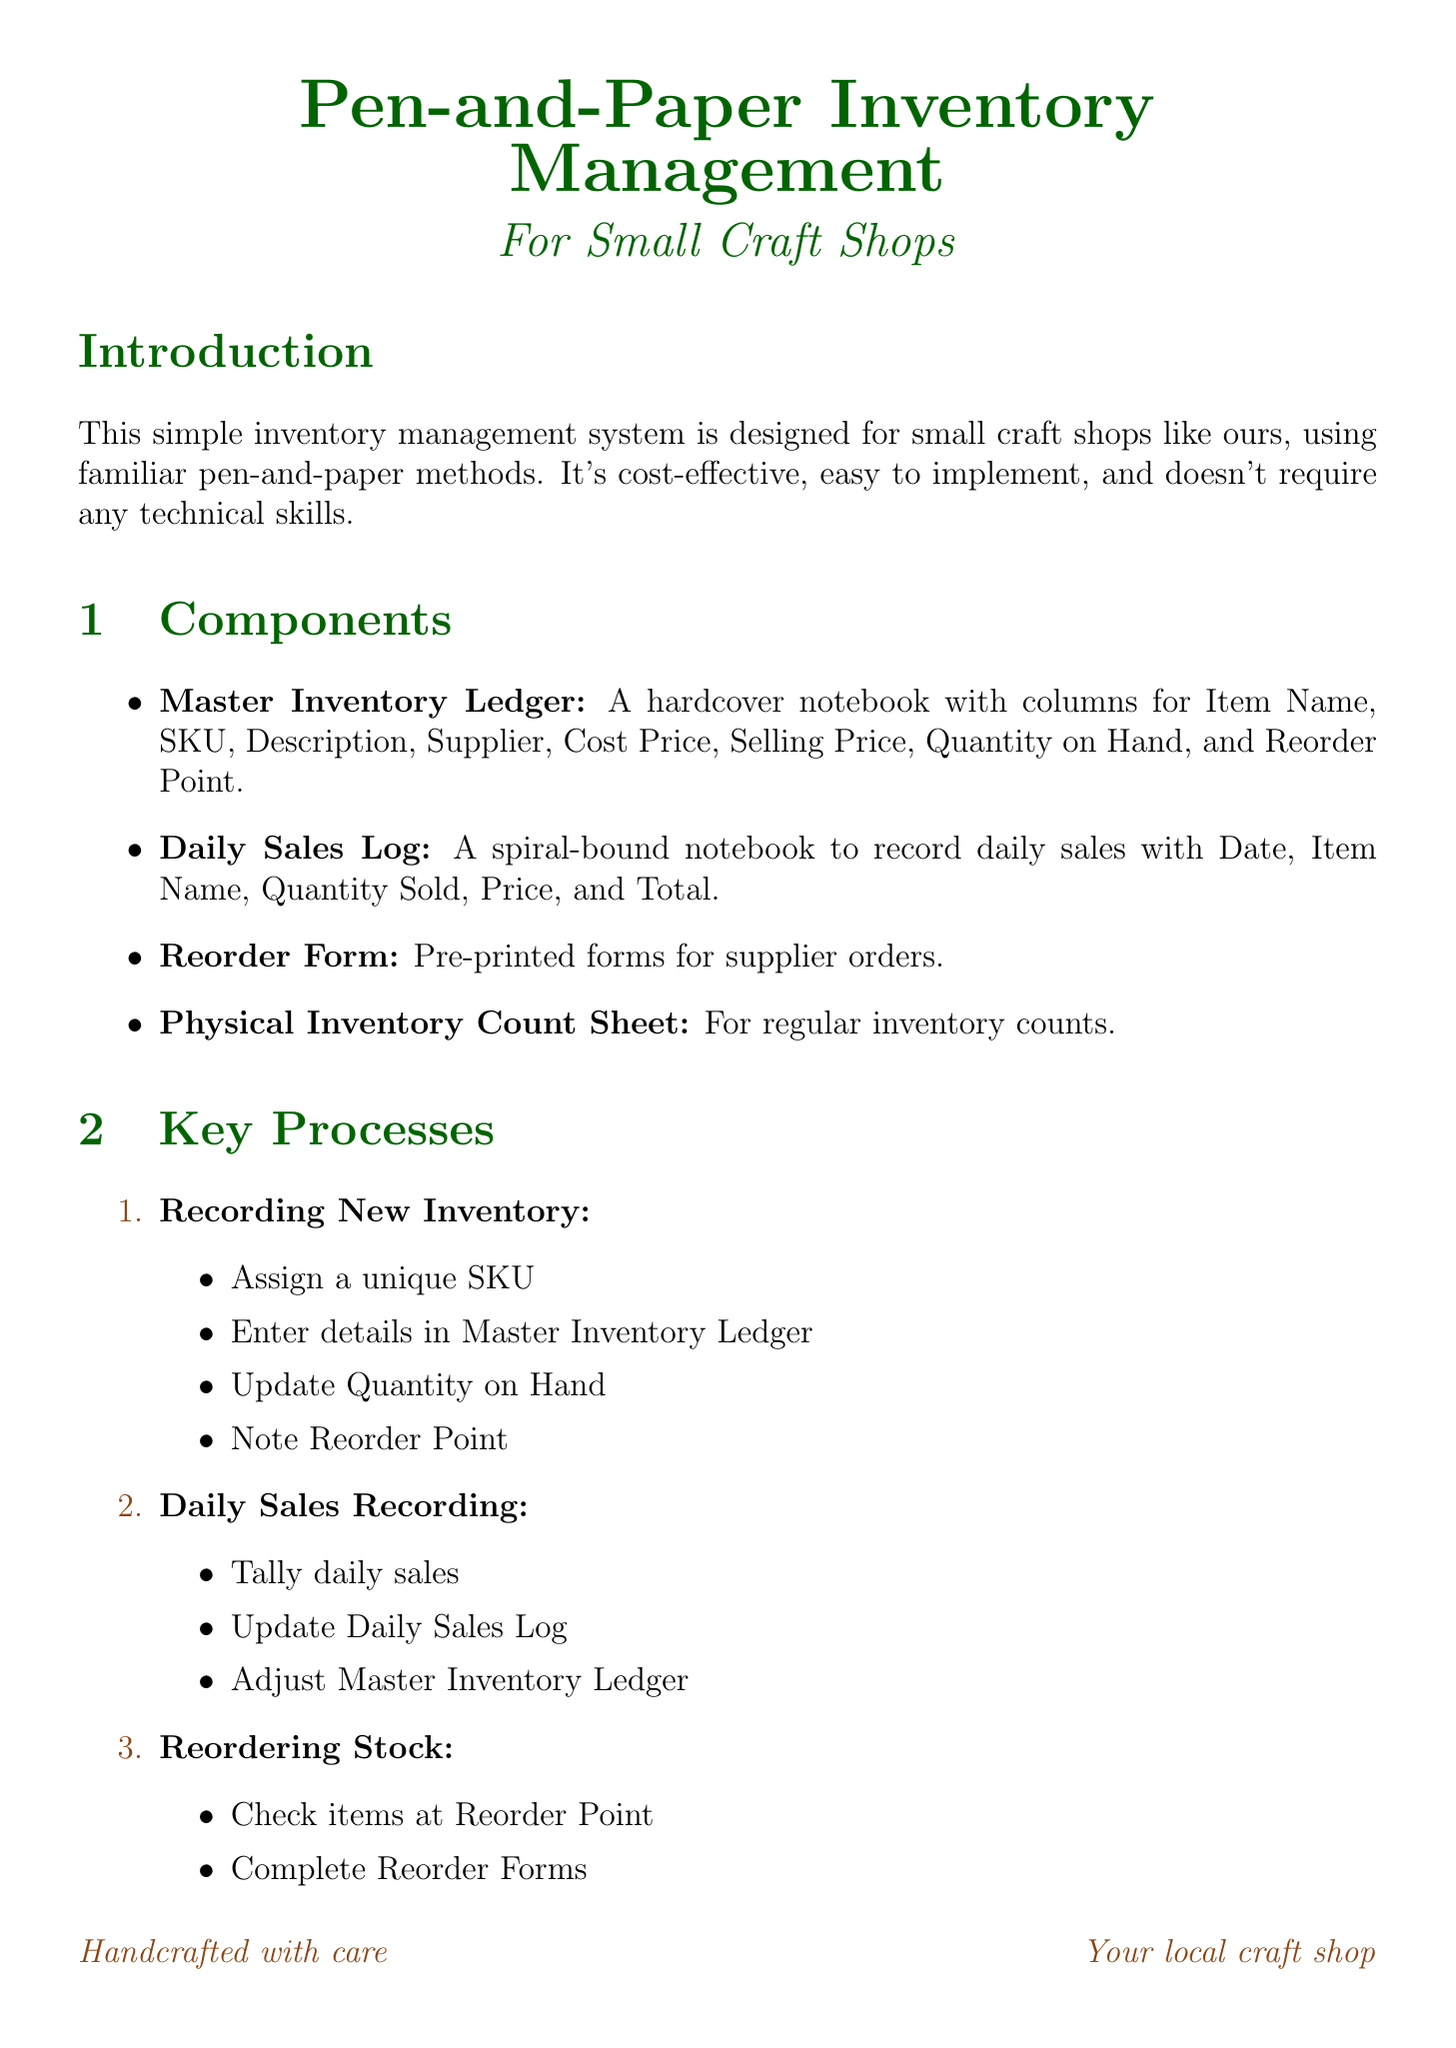What is the purpose of the manual? The purpose of the manual is to provide a simple, reliable method for tracking inventory without relying on digital technology.
Answer: To provide a simple, reliable method for tracking inventory without relying on digital technology What is the first component mentioned? The first component listed in the document is the Master Inventory Ledger.
Answer: Master Inventory Ledger How many columns are in the Daily Sales Log? The Daily Sales Log contains five columns as detailed in the document.
Answer: Five What is the SKU for the Hand-knitted Baby Blanket? The SKU for the Hand-knitted Baby Blanket is KNT-001, as specified in the sample inventory items section.
Answer: KNT-001 What step is involved in conducting physical inventory? One of the steps in conducting physical inventory is to compare actual quantities to expected quantities.
Answer: Compare actual quantities to expected quantities How often should physical inventory counts be conducted? The best practice states that physical inventory counts should be conducted monthly.
Answer: Monthly What is the cost price of the Scented Soy Candle? The cost price of the Scented Soy Candle is listed as $6.00 in the sample inventory items.
Answer: $6.00 What is a recommended method for corrections in the Master Inventory Ledger? The manual suggests to use a pencil for easy corrections in the Master Inventory Ledger.
Answer: Use a pencil What does the conclusion emphasize about the system? The conclusion emphasizes that the system provides a reliable, low-tech solution for small craft shops.
Answer: Provides a reliable, low-tech solution for small craft shops 